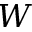Convert formula to latex. <formula><loc_0><loc_0><loc_500><loc_500>W</formula> 